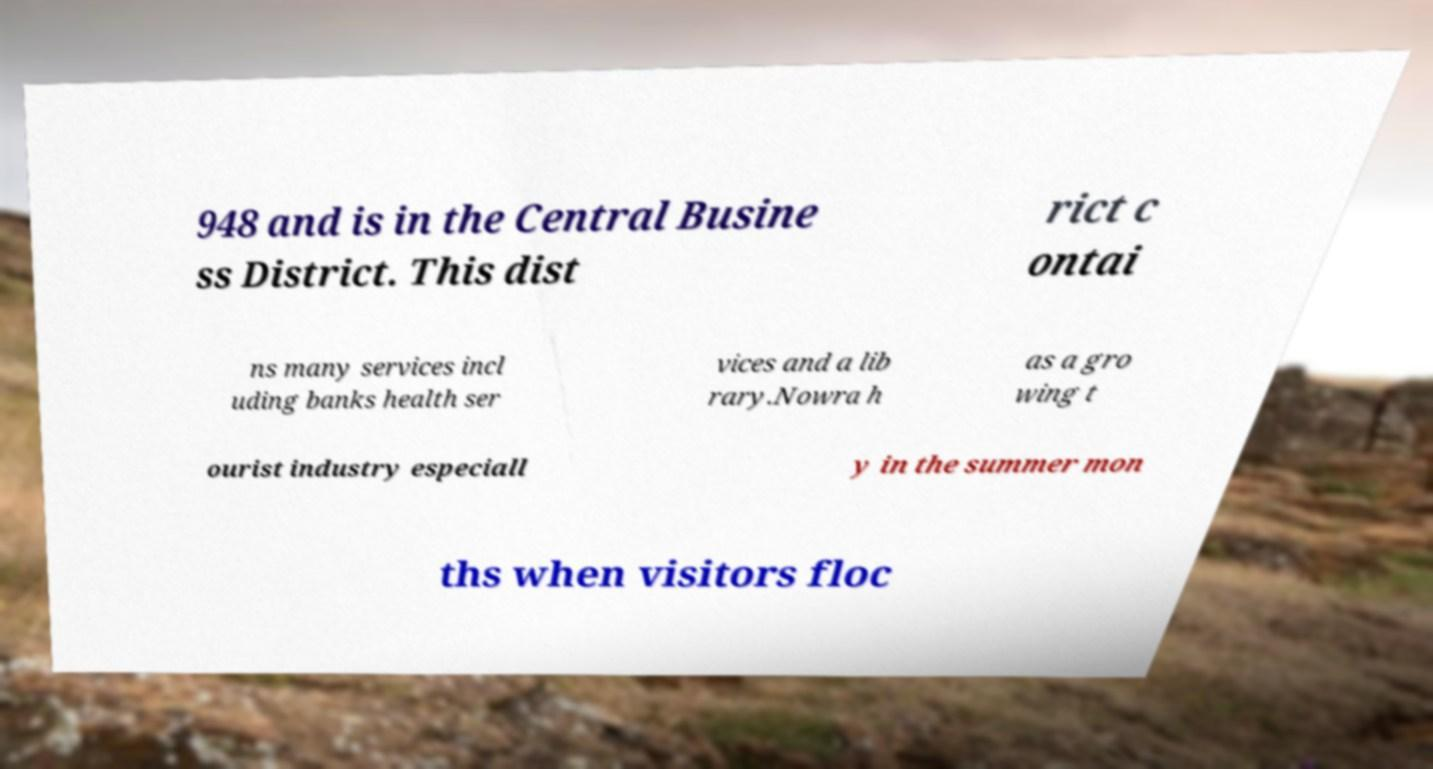Could you assist in decoding the text presented in this image and type it out clearly? 948 and is in the Central Busine ss District. This dist rict c ontai ns many services incl uding banks health ser vices and a lib rary.Nowra h as a gro wing t ourist industry especiall y in the summer mon ths when visitors floc 